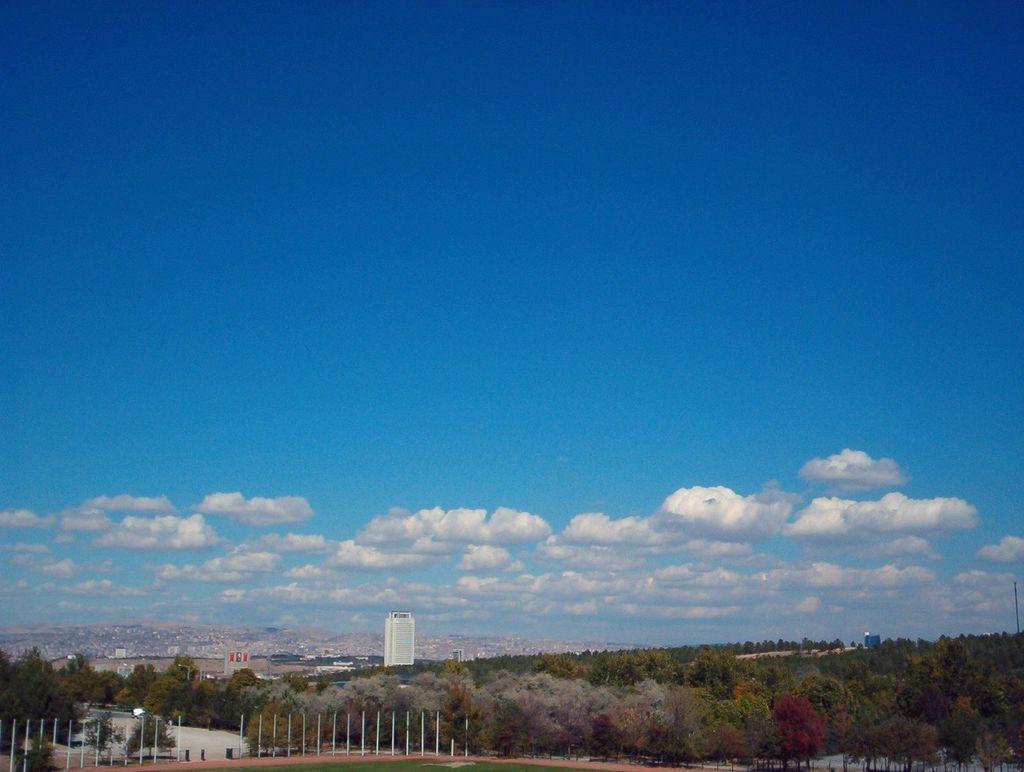Describe this image in one or two sentences. In this image in the center there are poles and there are trees. In the background there are buildings and the sky is cloudy. 